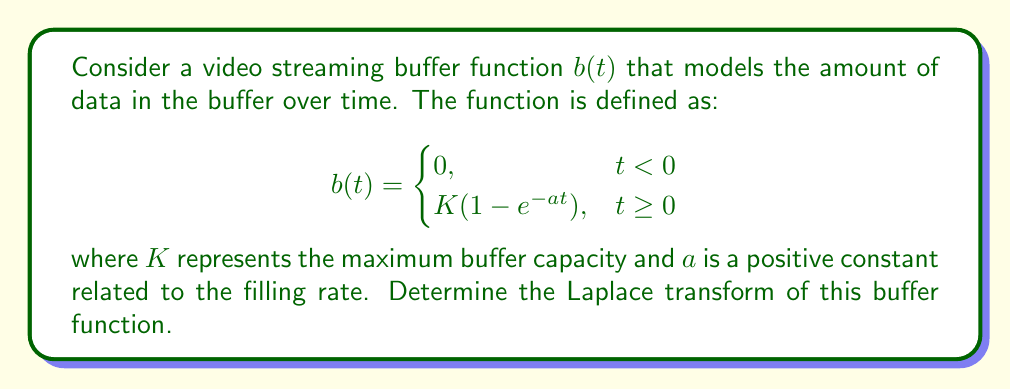Solve this math problem. To find the Laplace transform of the buffer function $b(t)$, we'll follow these steps:

1) The Laplace transform is defined as:

   $$\mathcal{L}\{f(t)\} = F(s) = \int_0^{\infty} f(t)e^{-st}dt$$

2) For our buffer function, we only need to consider the case where $t \geq 0$, as the function is zero for $t < 0$. So, we'll use:

   $$b(t) = K(1 - e^{-at}), \quad t \geq 0$$

3) Let's calculate the Laplace transform:

   $$\begin{align}
   \mathcal{L}\{b(t)\} &= \int_0^{\infty} K(1 - e^{-at})e^{-st}dt \\
   &= K\int_0^{\infty} e^{-st}dt - K\int_0^{\infty} e^{-(a+s)t}dt
   \end{align}$$

4) Evaluate the first integral:

   $$\int_0^{\infty} e^{-st}dt = \left[-\frac{1}{s}e^{-st}\right]_0^{\infty} = \frac{1}{s}$$

5) Evaluate the second integral:

   $$\int_0^{\infty} e^{-(a+s)t}dt = \left[-\frac{1}{a+s}e^{-(a+s)t}\right]_0^{\infty} = \frac{1}{a+s}$$

6) Combining the results:

   $$\begin{align}
   \mathcal{L}\{b(t)\} &= K\left(\frac{1}{s} - \frac{1}{a+s}\right) \\
   &= K\left(\frac{a+s}{s(a+s)} - \frac{s}{s(a+s)}\right) \\
   &= K\left(\frac{a}{s(a+s)}\right)
   \end{align}$$

7) Therefore, the Laplace transform of the buffer function is:

   $$B(s) = \frac{Ka}{s(s+a)}$$

This result represents the buffer function in the frequency domain, which can be useful for analyzing the system's behavior and performance in video streaming applications.
Answer: $$B(s) = \frac{Ka}{s(s+a)}$$ 